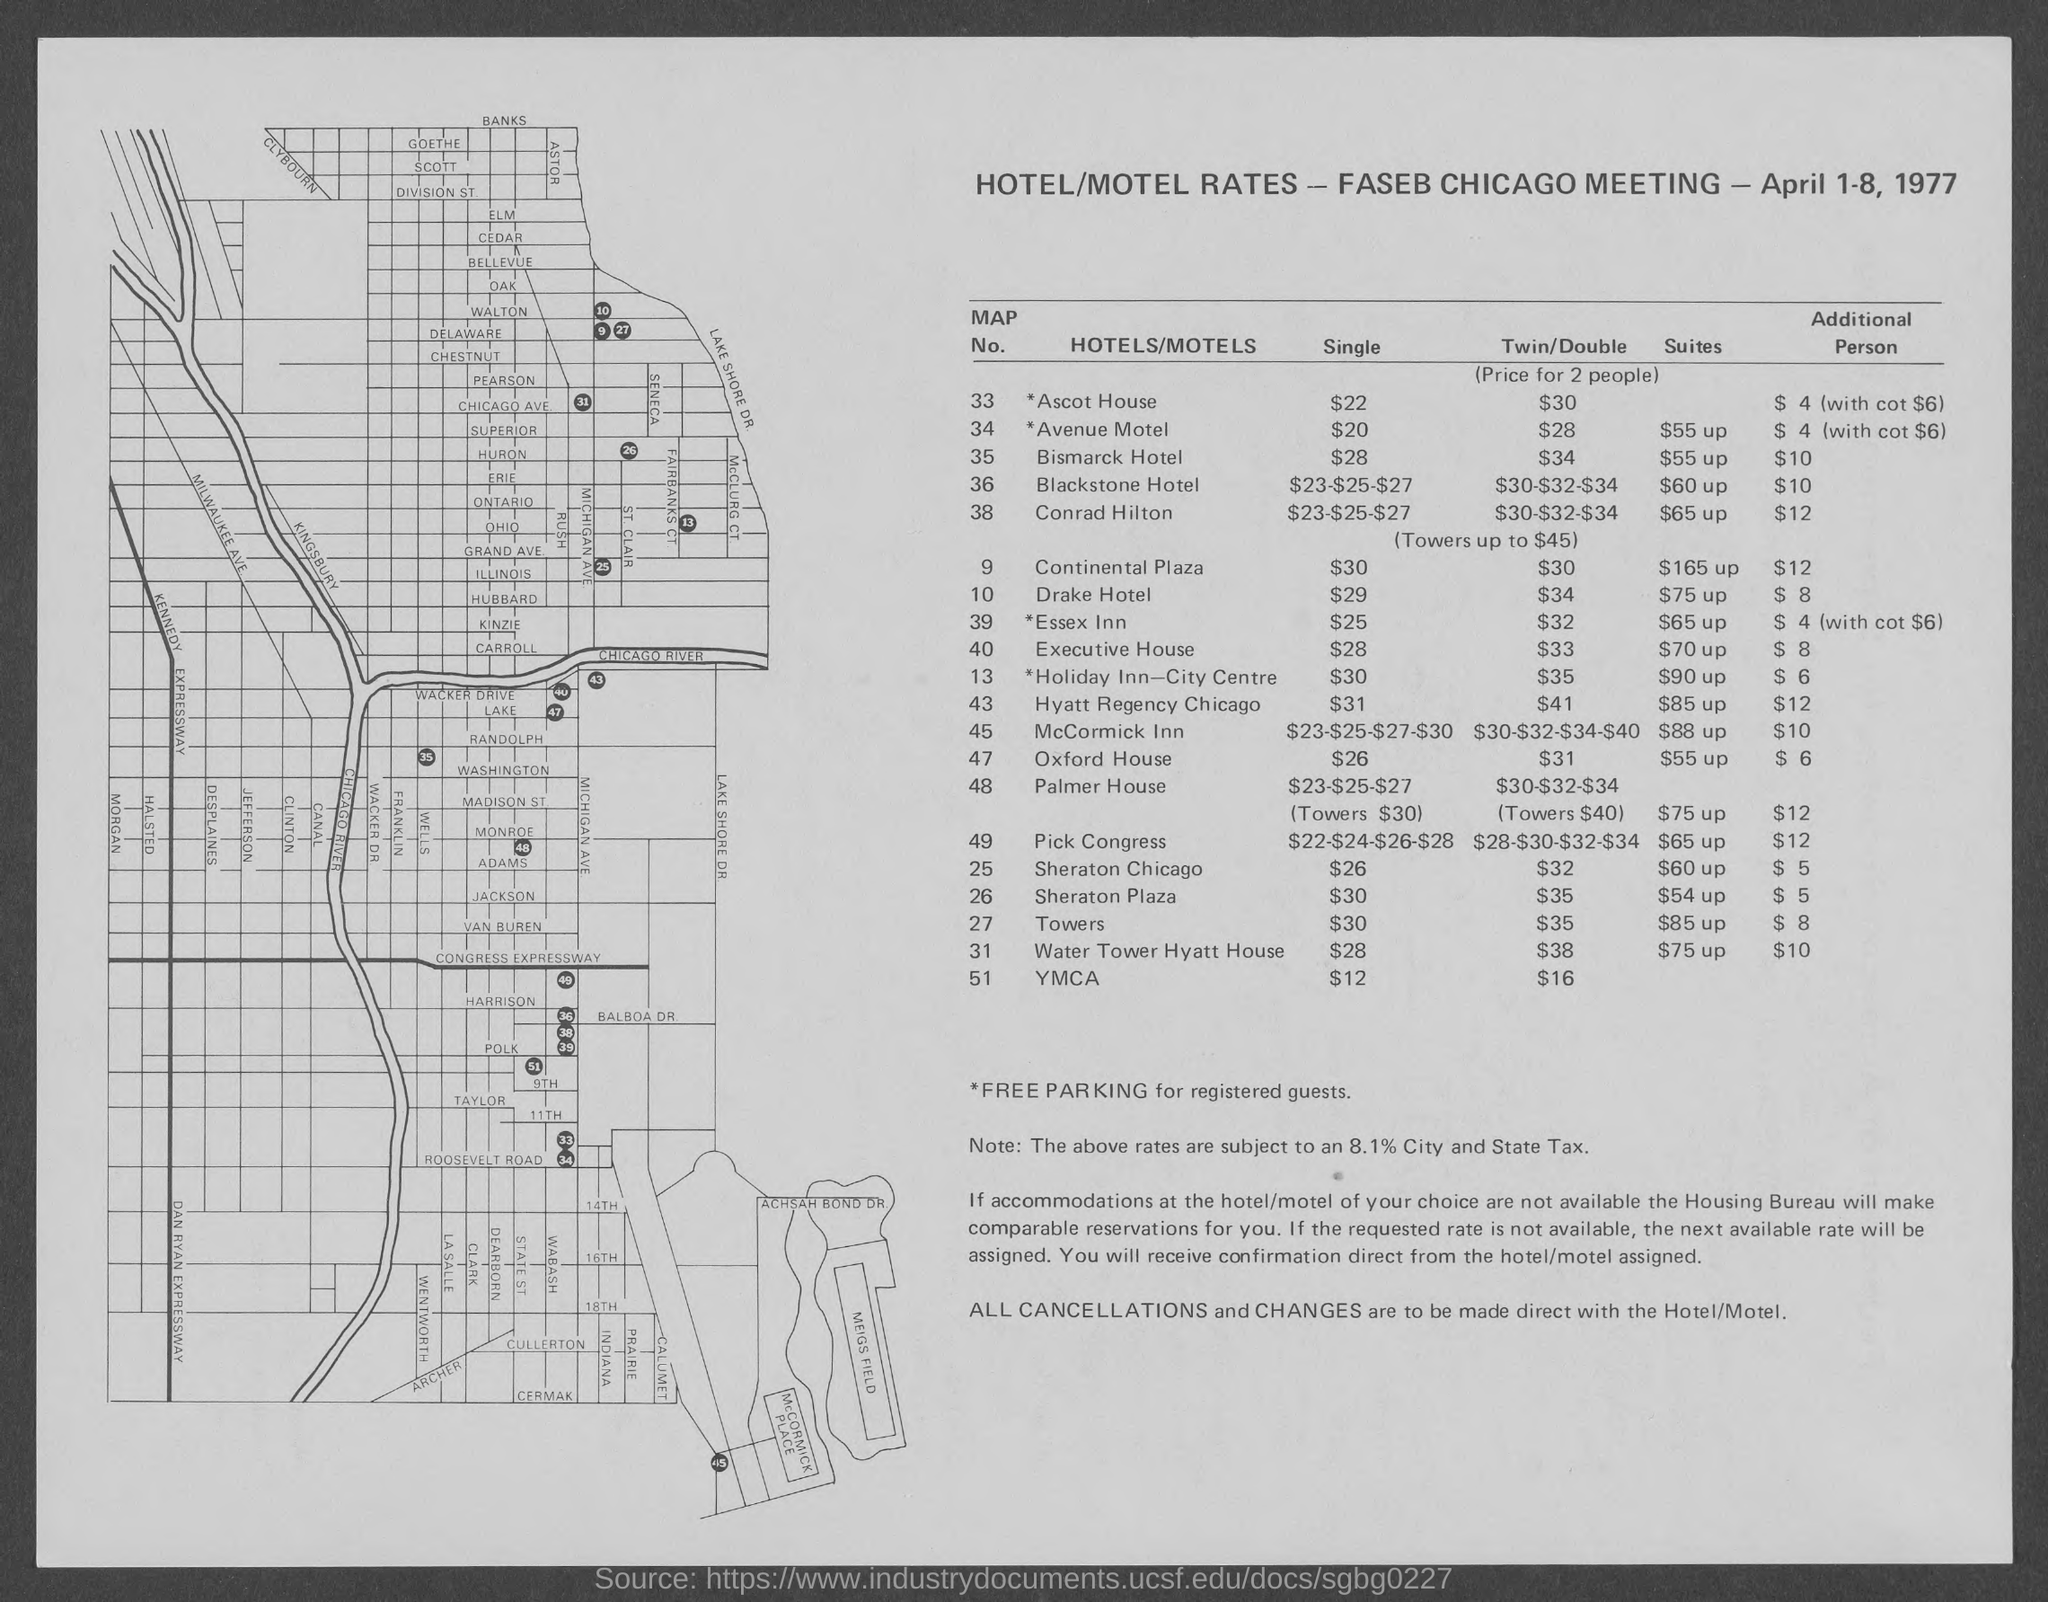What is the map no. for *ascot house ?
Offer a terse response. 33. What is the map no. for *avenue  motel ?
Offer a terse response. 34. What is the map no. for bismarck hotel ?
Provide a succinct answer. 35. What is the map no. for blackstone hotel ?
Provide a short and direct response. 36. What is the map no. for conrad hilton ?
Your answer should be very brief. 38. What is the map no. for ymca ?
Provide a short and direct response. 51. What is the map no. for pick congress ?
Ensure brevity in your answer.  49. What is the map no. for drake hotel ?
Give a very brief answer. 10. What is the map no. of palmer house ?
Offer a terse response. 48. What is the map no. for sheraton plaza?
Offer a very short reply. 26. 